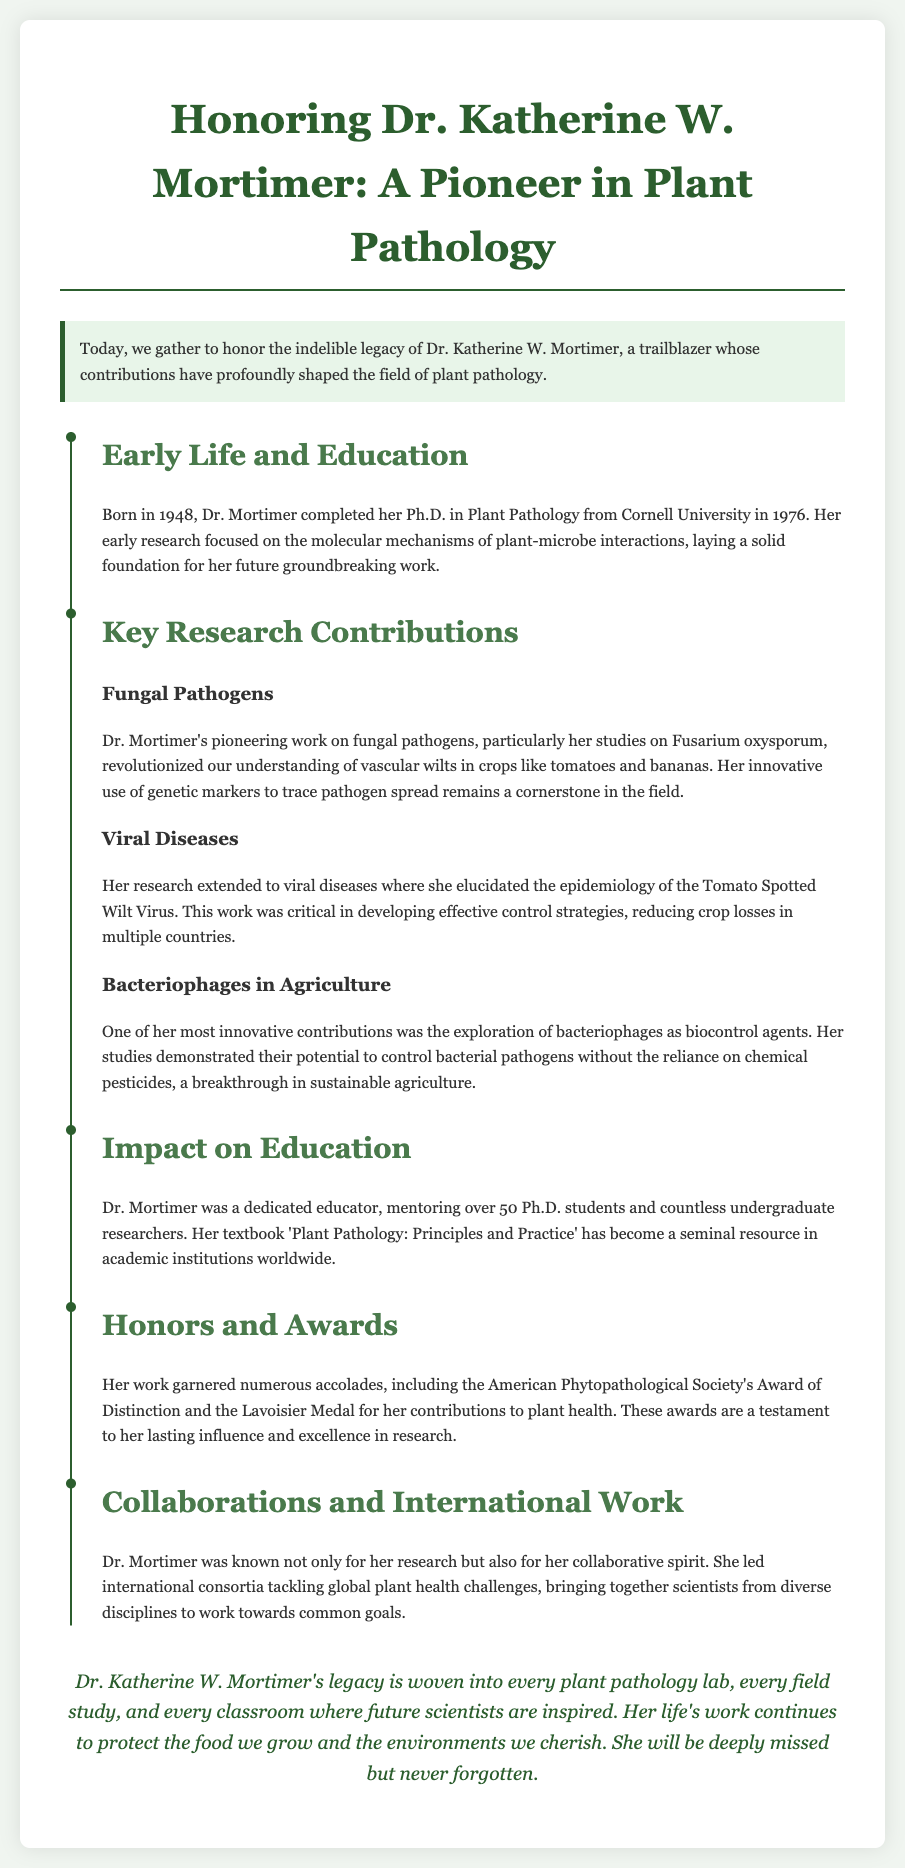what is Dr. Katherine W. Mortimer's birth year? The document states that Dr. Mortimer was born in 1948.
Answer: 1948 what university did Dr. Mortimer obtain her Ph.D. from? Dr. Mortimer completed her Ph.D. in Plant Pathology from Cornell University.
Answer: Cornell University which pathogen was a focus of Dr. Mortimer's pioneering work? Her studies on Fusarium oxysporum were highlighted as a significant focus of her research.
Answer: Fusarium oxysporum how many Ph.D. students did Dr. Mortimer mentor? The document mentions that she mentored over 50 Ph.D. students.
Answer: over 50 which award did Dr. Mortimer receive from the American Phytopathological Society? She received the Award of Distinction from the American Phytopathological Society.
Answer: Award of Distinction what major innovation did Dr. Mortimer explore in her research? The document noted her exploration of bacteriophages as biocontrol agents.
Answer: bacteriophages what is the title of Dr. Mortimer's textbook? The textbook she authored is titled 'Plant Pathology: Principles and Practice'.
Answer: Plant Pathology: Principles and Practice how many accolades and honors are mentioned in the document? The specific number of accolades is not stated, but two notable awards are highlighted: the Award of Distinction and the Lavoisier Medal.
Answer: two what type of spirit was Dr. Mortimer known for regarding her collaborations? She was known for her collaborative spirit, bringing together scientists for global plant health challenges.
Answer: collaborative spirit 